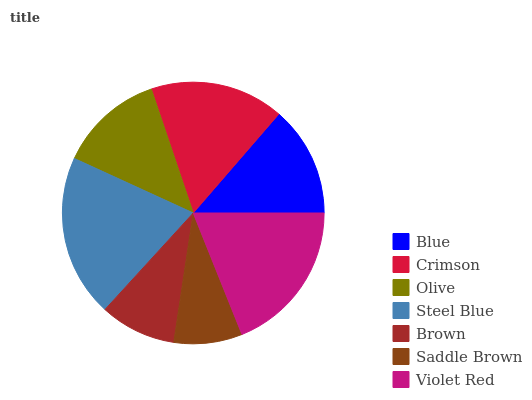Is Saddle Brown the minimum?
Answer yes or no. Yes. Is Steel Blue the maximum?
Answer yes or no. Yes. Is Crimson the minimum?
Answer yes or no. No. Is Crimson the maximum?
Answer yes or no. No. Is Crimson greater than Blue?
Answer yes or no. Yes. Is Blue less than Crimson?
Answer yes or no. Yes. Is Blue greater than Crimson?
Answer yes or no. No. Is Crimson less than Blue?
Answer yes or no. No. Is Blue the high median?
Answer yes or no. Yes. Is Blue the low median?
Answer yes or no. Yes. Is Olive the high median?
Answer yes or no. No. Is Violet Red the low median?
Answer yes or no. No. 